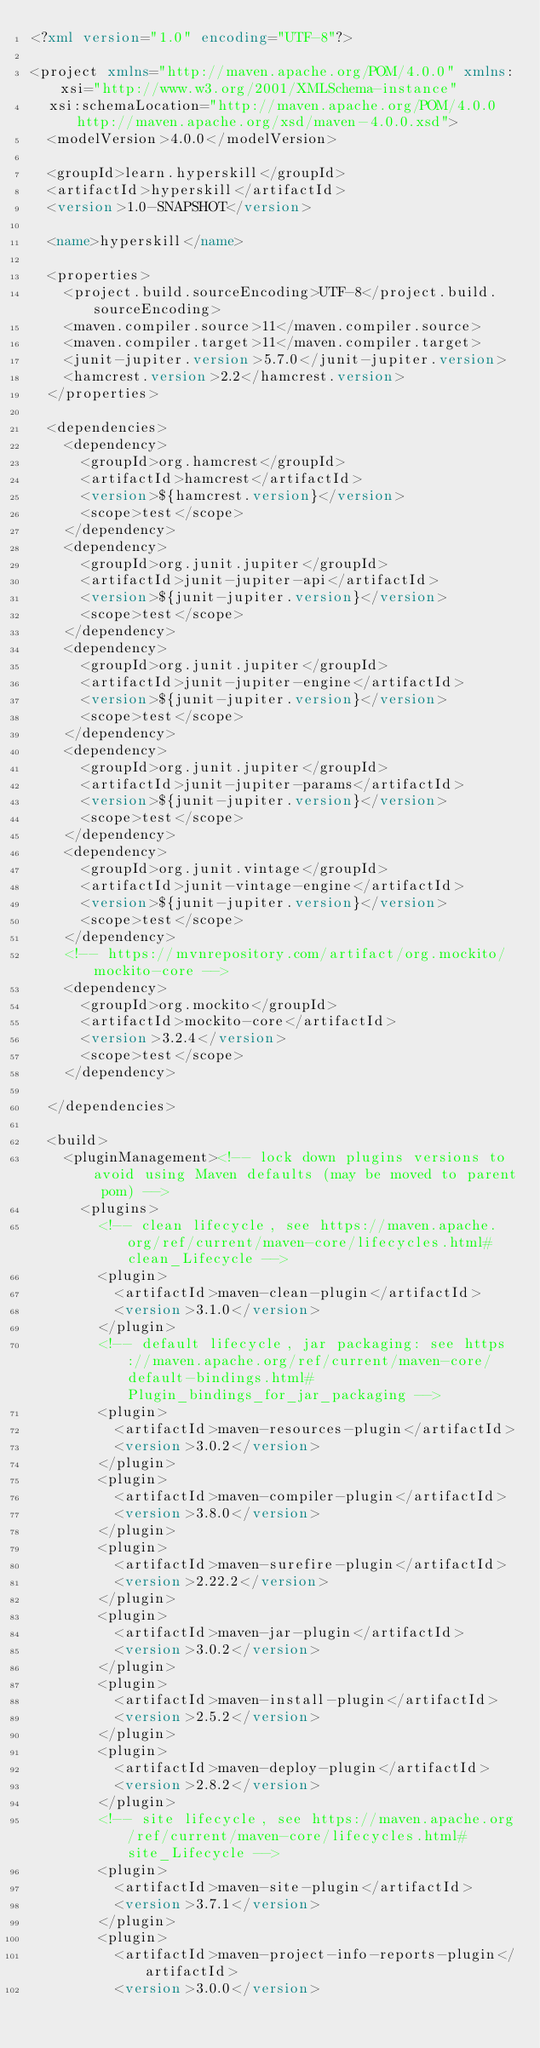<code> <loc_0><loc_0><loc_500><loc_500><_XML_><?xml version="1.0" encoding="UTF-8"?>

<project xmlns="http://maven.apache.org/POM/4.0.0" xmlns:xsi="http://www.w3.org/2001/XMLSchema-instance"
  xsi:schemaLocation="http://maven.apache.org/POM/4.0.0 http://maven.apache.org/xsd/maven-4.0.0.xsd">
  <modelVersion>4.0.0</modelVersion>

  <groupId>learn.hyperskill</groupId>
  <artifactId>hyperskill</artifactId>
  <version>1.0-SNAPSHOT</version>

  <name>hyperskill</name>

  <properties>
    <project.build.sourceEncoding>UTF-8</project.build.sourceEncoding>
    <maven.compiler.source>11</maven.compiler.source>
    <maven.compiler.target>11</maven.compiler.target>
    <junit-jupiter.version>5.7.0</junit-jupiter.version>
    <hamcrest.version>2.2</hamcrest.version>
  </properties>

  <dependencies>
    <dependency>
      <groupId>org.hamcrest</groupId>
      <artifactId>hamcrest</artifactId>
      <version>${hamcrest.version}</version>
      <scope>test</scope>
    </dependency>
    <dependency>
      <groupId>org.junit.jupiter</groupId>
      <artifactId>junit-jupiter-api</artifactId>
      <version>${junit-jupiter.version}</version>
      <scope>test</scope>
    </dependency>
    <dependency>
      <groupId>org.junit.jupiter</groupId>
      <artifactId>junit-jupiter-engine</artifactId>
      <version>${junit-jupiter.version}</version>
      <scope>test</scope>
    </dependency>
    <dependency>
      <groupId>org.junit.jupiter</groupId>
      <artifactId>junit-jupiter-params</artifactId>
      <version>${junit-jupiter.version}</version>
      <scope>test</scope>
    </dependency>
    <dependency>
      <groupId>org.junit.vintage</groupId>
      <artifactId>junit-vintage-engine</artifactId>
      <version>${junit-jupiter.version}</version>
      <scope>test</scope>
    </dependency>
    <!-- https://mvnrepository.com/artifact/org.mockito/mockito-core -->
    <dependency>
      <groupId>org.mockito</groupId>
      <artifactId>mockito-core</artifactId>
      <version>3.2.4</version>
      <scope>test</scope>
    </dependency>

  </dependencies>

  <build>
    <pluginManagement><!-- lock down plugins versions to avoid using Maven defaults (may be moved to parent pom) -->
      <plugins>
        <!-- clean lifecycle, see https://maven.apache.org/ref/current/maven-core/lifecycles.html#clean_Lifecycle -->
        <plugin>
          <artifactId>maven-clean-plugin</artifactId>
          <version>3.1.0</version>
        </plugin>
        <!-- default lifecycle, jar packaging: see https://maven.apache.org/ref/current/maven-core/default-bindings.html#Plugin_bindings_for_jar_packaging -->
        <plugin>
          <artifactId>maven-resources-plugin</artifactId>
          <version>3.0.2</version>
        </plugin>
        <plugin>
          <artifactId>maven-compiler-plugin</artifactId>
          <version>3.8.0</version>
        </plugin>
        <plugin>
          <artifactId>maven-surefire-plugin</artifactId>
          <version>2.22.2</version>
        </plugin>
        <plugin>
          <artifactId>maven-jar-plugin</artifactId>
          <version>3.0.2</version>
        </plugin>
        <plugin>
          <artifactId>maven-install-plugin</artifactId>
          <version>2.5.2</version>
        </plugin>
        <plugin>
          <artifactId>maven-deploy-plugin</artifactId>
          <version>2.8.2</version>
        </plugin>
        <!-- site lifecycle, see https://maven.apache.org/ref/current/maven-core/lifecycles.html#site_Lifecycle -->
        <plugin>
          <artifactId>maven-site-plugin</artifactId>
          <version>3.7.1</version>
        </plugin>
        <plugin>
          <artifactId>maven-project-info-reports-plugin</artifactId>
          <version>3.0.0</version></code> 